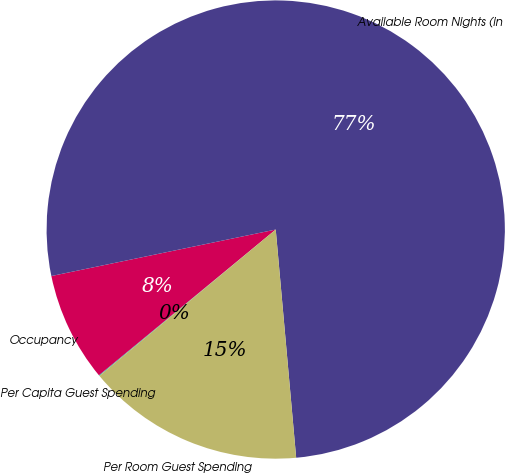Convert chart. <chart><loc_0><loc_0><loc_500><loc_500><pie_chart><fcel>Per Capita Guest Spending<fcel>Occupancy<fcel>Available Room Nights (in<fcel>Per Room Guest Spending<nl><fcel>0.05%<fcel>7.72%<fcel>76.83%<fcel>15.4%<nl></chart> 